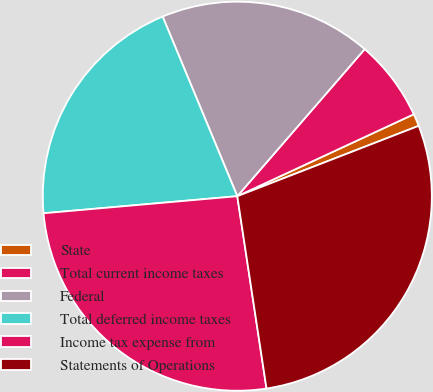Convert chart to OTSL. <chart><loc_0><loc_0><loc_500><loc_500><pie_chart><fcel>State<fcel>Total current income taxes<fcel>Federal<fcel>Total deferred income taxes<fcel>Income tax expense from<fcel>Statements of Operations<nl><fcel>1.03%<fcel>6.72%<fcel>17.63%<fcel>20.13%<fcel>26.0%<fcel>28.49%<nl></chart> 